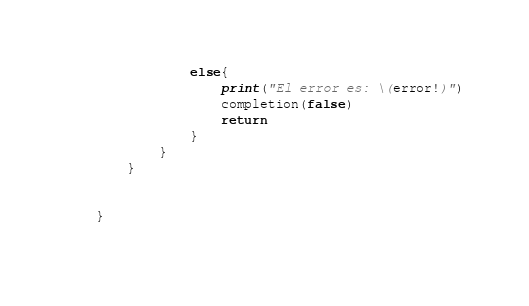<code> <loc_0><loc_0><loc_500><loc_500><_Swift_>                else{
                    print("El error es: \(error!)")
                    completion(false)
                    return
                }
            }
        }
        
        
    }
    </code> 